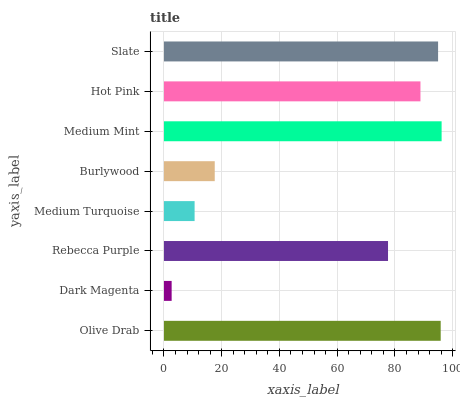Is Dark Magenta the minimum?
Answer yes or no. Yes. Is Medium Mint the maximum?
Answer yes or no. Yes. Is Rebecca Purple the minimum?
Answer yes or no. No. Is Rebecca Purple the maximum?
Answer yes or no. No. Is Rebecca Purple greater than Dark Magenta?
Answer yes or no. Yes. Is Dark Magenta less than Rebecca Purple?
Answer yes or no. Yes. Is Dark Magenta greater than Rebecca Purple?
Answer yes or no. No. Is Rebecca Purple less than Dark Magenta?
Answer yes or no. No. Is Hot Pink the high median?
Answer yes or no. Yes. Is Rebecca Purple the low median?
Answer yes or no. Yes. Is Slate the high median?
Answer yes or no. No. Is Hot Pink the low median?
Answer yes or no. No. 